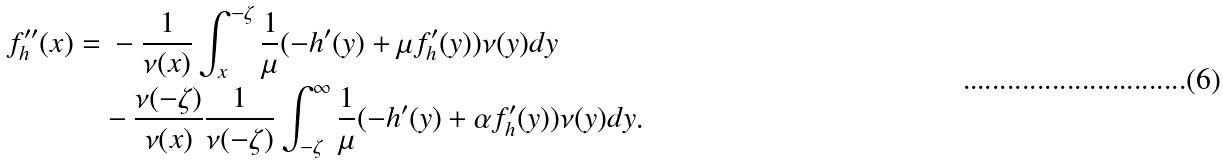<formula> <loc_0><loc_0><loc_500><loc_500>f _ { h } ^ { \prime \prime } ( x ) = & \ - \frac { 1 } { \nu ( x ) } \int _ { x } ^ { - \zeta } \frac { 1 } { \mu } ( - h ^ { \prime } ( y ) + \mu f _ { h } ^ { \prime } ( y ) ) \nu ( y ) d y \\ & - \frac { \nu ( - \zeta ) } { \nu ( x ) } \frac { 1 } { \nu ( - \zeta ) } \int _ { - \zeta } ^ { \infty } \frac { 1 } { \mu } ( - h ^ { \prime } ( y ) + \alpha f _ { h } ^ { \prime } ( y ) ) \nu ( y ) d y .</formula> 